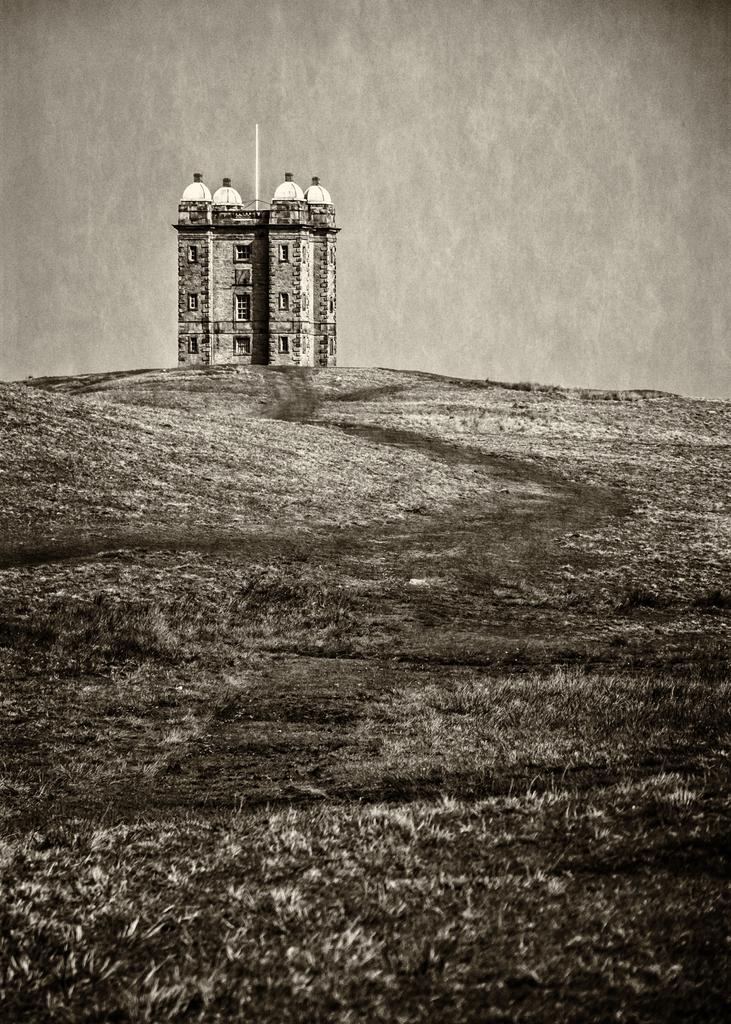What is the color scheme of the image? The image is black and white. What type of structure can be seen in the image? There is a building in the image. Where is the building situated in relation to other elements in the image? The building is located on a path. What is the price of the vessel in the image? There is no vessel present in the image, so it is not possible to determine its price. 